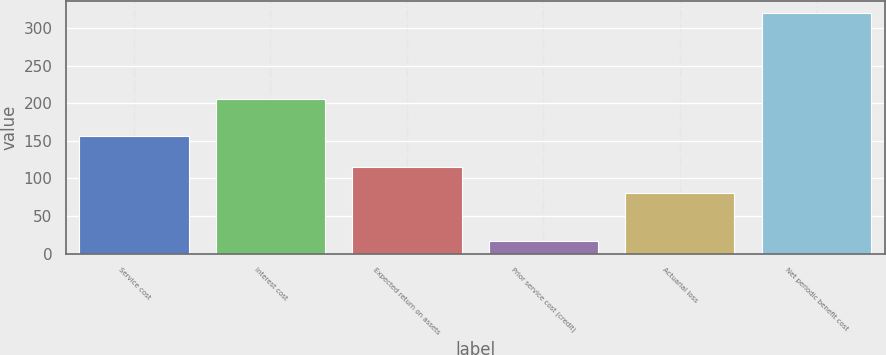Convert chart to OTSL. <chart><loc_0><loc_0><loc_500><loc_500><bar_chart><fcel>Service cost<fcel>Interest cost<fcel>Expected return on assets<fcel>Prior service cost (credit)<fcel>Actuarial loss<fcel>Net periodic benefit cost<nl><fcel>156<fcel>205<fcel>115<fcel>17<fcel>81<fcel>320<nl></chart> 